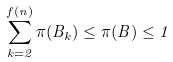Convert formula to latex. <formula><loc_0><loc_0><loc_500><loc_500>\sum _ { k = 2 } ^ { f ( n ) } \pi ( B _ { k } ) \leq \pi ( B ) \leq 1</formula> 